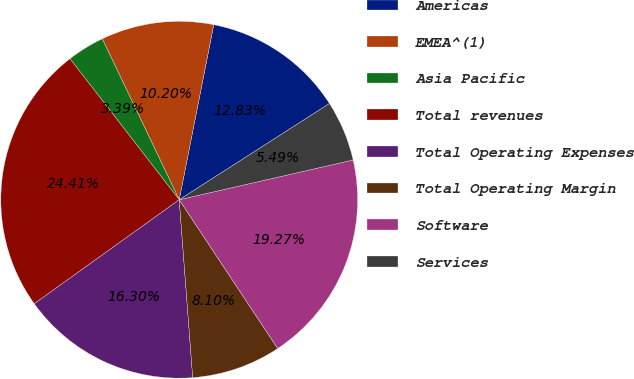Convert chart. <chart><loc_0><loc_0><loc_500><loc_500><pie_chart><fcel>Americas<fcel>EMEA^(1)<fcel>Asia Pacific<fcel>Total revenues<fcel>Total Operating Expenses<fcel>Total Operating Margin<fcel>Software<fcel>Services<nl><fcel>12.83%<fcel>10.2%<fcel>3.39%<fcel>24.41%<fcel>16.3%<fcel>8.1%<fcel>19.27%<fcel>5.49%<nl></chart> 